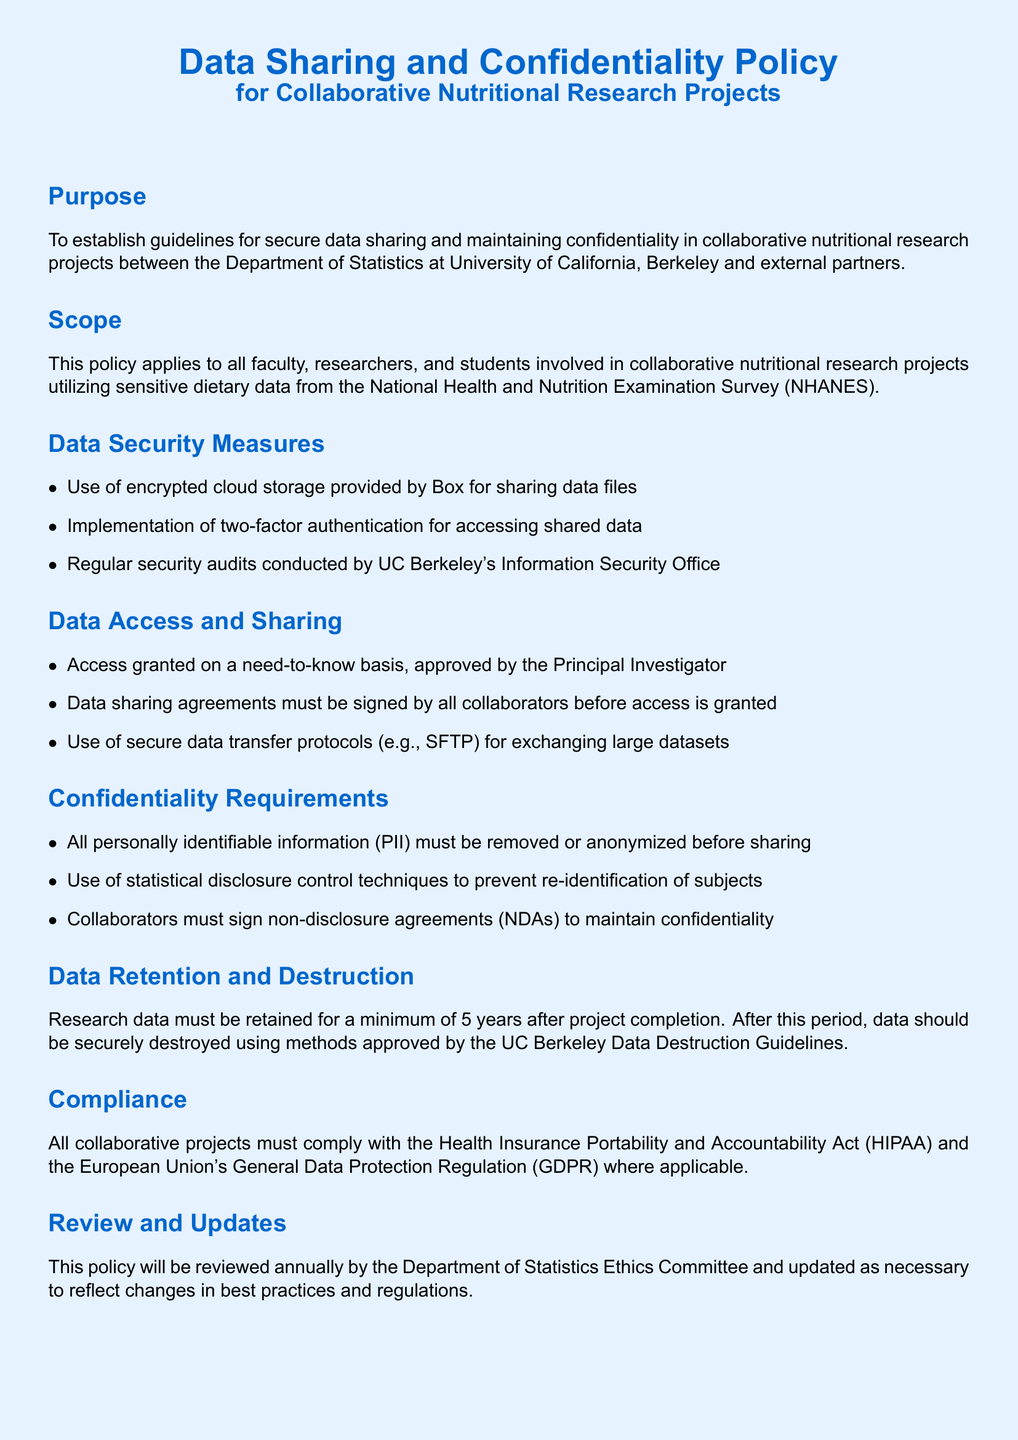What is the purpose of the document? The purpose describes the guidelines for secure data sharing and maintaining confidentiality in collaborative research projects.
Answer: Establish guidelines for secure data sharing and maintaining confidentiality What is the minimum data retention period? The minimum data retention period is specified in the document.
Answer: 5 years Which organization conducts regular security audits? The organization responsible for conducting audits is stated in the document.
Answer: UC Berkeley's Information Security Office What must collaborators sign before accessing data? The document mentions a requirement for collaborators before they can access sensitive data.
Answer: Non-disclosure agreements (NDAs) What data sharing protocol is recommended for exchanging large datasets? The document specifies a secure protocol for data exchanges.
Answer: SFTP What regulation must all projects comply with? The primary regulation mentioned in the compliance section covers privacy and security.
Answer: HIPAA Who must approve access to data? The document clearly states the individual responsible for approving data access.
Answer: Principal Investigator What technique must be used to prevent re-identification of subjects? The document outlines a required technique for ensuring confidentiality in research.
Answer: Statistical disclosure control techniques 